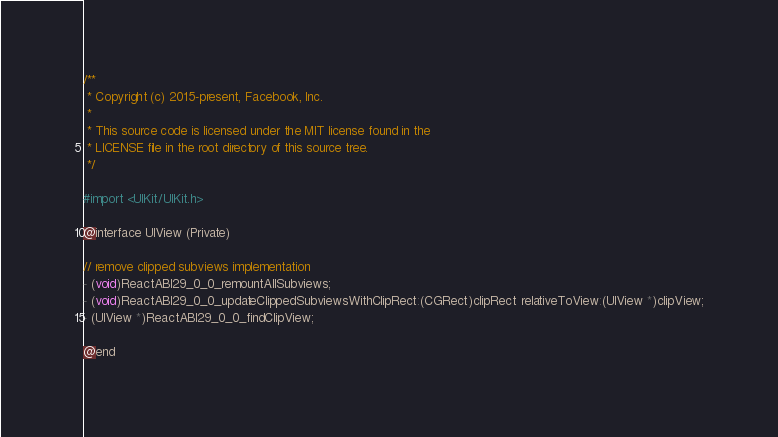<code> <loc_0><loc_0><loc_500><loc_500><_C_>/**
 * Copyright (c) 2015-present, Facebook, Inc.
 *
 * This source code is licensed under the MIT license found in the
 * LICENSE file in the root directory of this source tree.
 */

#import <UIKit/UIKit.h>

@interface UIView (Private)

// remove clipped subviews implementation
- (void)ReactABI29_0_0_remountAllSubviews;
- (void)ReactABI29_0_0_updateClippedSubviewsWithClipRect:(CGRect)clipRect relativeToView:(UIView *)clipView;
- (UIView *)ReactABI29_0_0_findClipView;

@end
</code> 